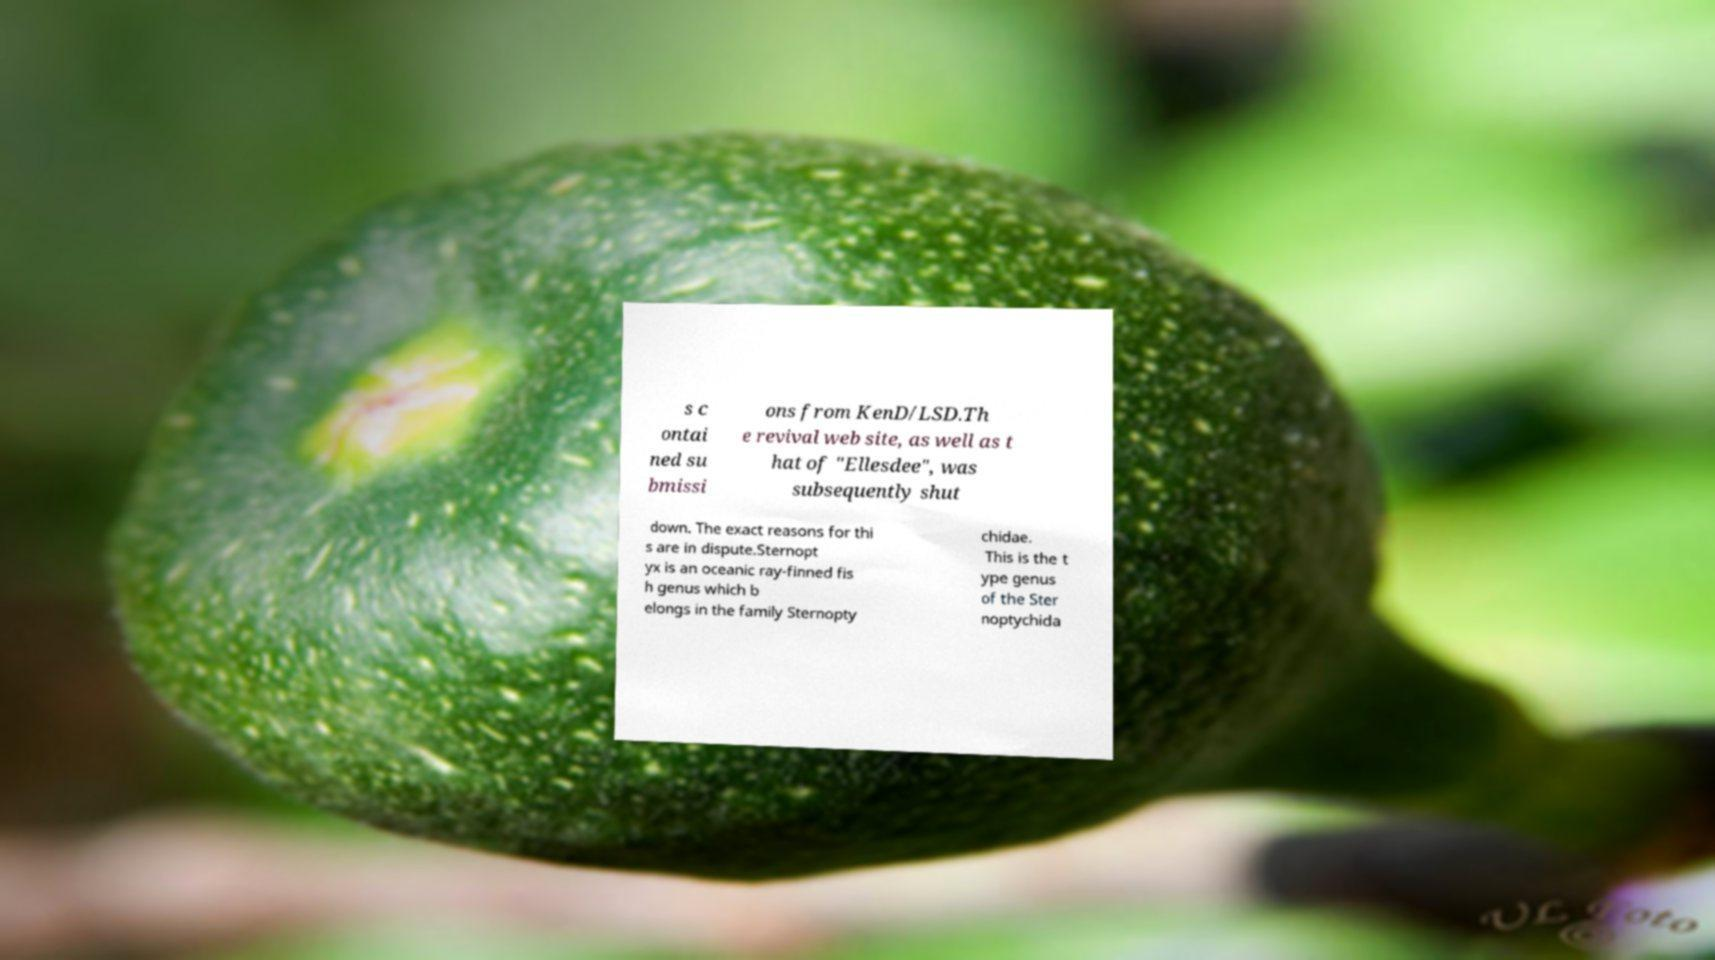There's text embedded in this image that I need extracted. Can you transcribe it verbatim? s c ontai ned su bmissi ons from KenD/LSD.Th e revival web site, as well as t hat of "Ellesdee", was subsequently shut down. The exact reasons for thi s are in dispute.Sternopt yx is an oceanic ray-finned fis h genus which b elongs in the family Sternopty chidae. This is the t ype genus of the Ster noptychida 